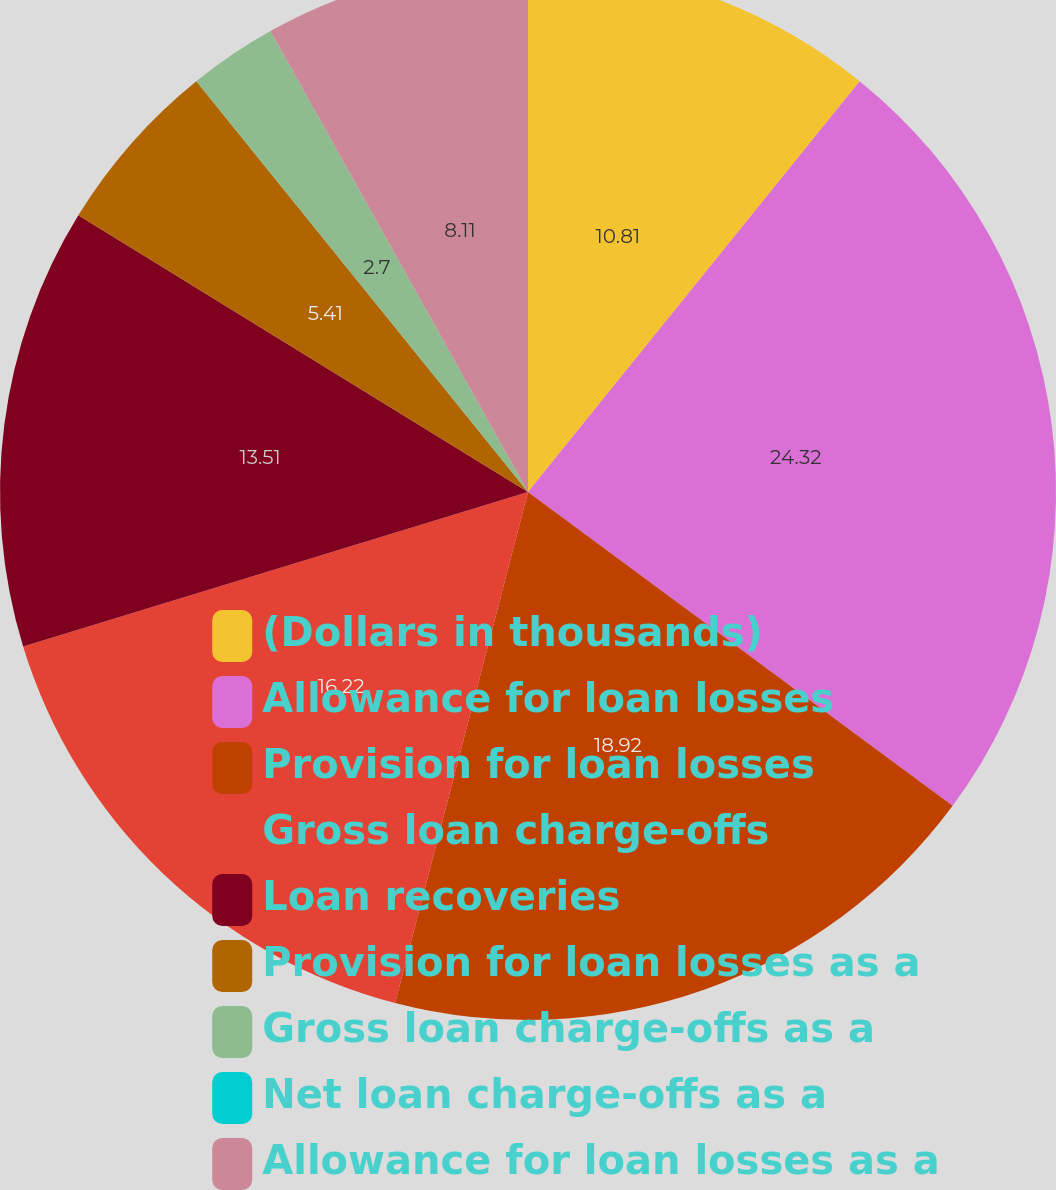Convert chart. <chart><loc_0><loc_0><loc_500><loc_500><pie_chart><fcel>(Dollars in thousands)<fcel>Allowance for loan losses<fcel>Provision for loan losses<fcel>Gross loan charge-offs<fcel>Loan recoveries<fcel>Provision for loan losses as a<fcel>Gross loan charge-offs as a<fcel>Net loan charge-offs as a<fcel>Allowance for loan losses as a<nl><fcel>10.81%<fcel>24.32%<fcel>18.92%<fcel>16.22%<fcel>13.51%<fcel>5.41%<fcel>2.7%<fcel>0.0%<fcel>8.11%<nl></chart> 